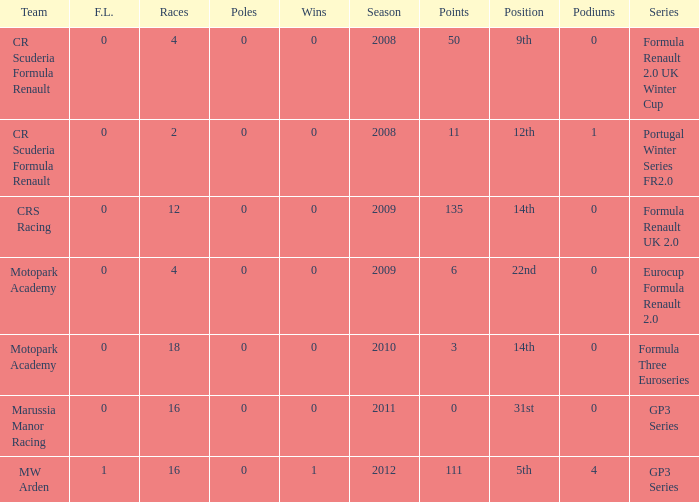What is the least amount of podiums? 0.0. 